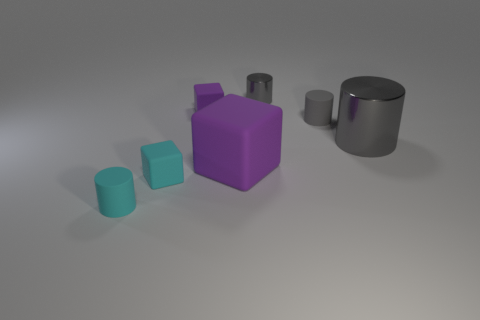How many gray cylinders must be subtracted to get 1 gray cylinders? 2 Subtract all blue cubes. How many gray cylinders are left? 3 Subtract all big cylinders. How many cylinders are left? 3 Subtract all cyan cylinders. How many cylinders are left? 3 Subtract all green cylinders. Subtract all red cubes. How many cylinders are left? 4 Add 1 small rubber objects. How many objects exist? 8 Subtract all cubes. How many objects are left? 4 Add 3 cylinders. How many cylinders are left? 7 Add 6 large purple cubes. How many large purple cubes exist? 7 Subtract 0 green spheres. How many objects are left? 7 